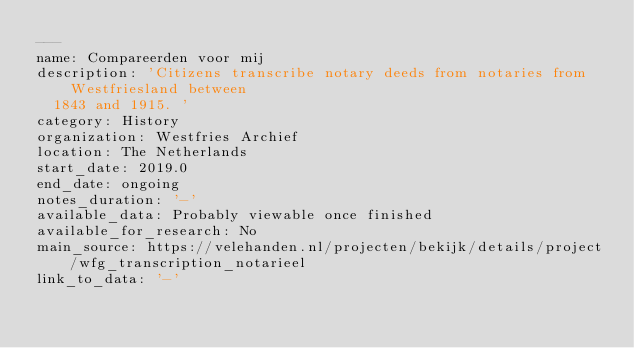Convert code to text. <code><loc_0><loc_0><loc_500><loc_500><_YAML_>---
name: Compareerden voor mij
description: 'Citizens transcribe notary deeds from notaries from Westfriesland between
  1843 and 1915. '
category: History
organization: Westfries Archief
location: The Netherlands
start_date: 2019.0
end_date: ongoing
notes_duration: '-'
available_data: Probably viewable once finished
available_for_research: No
main_source: https://velehanden.nl/projecten/bekijk/details/project/wfg_transcription_notarieel
link_to_data: '-'
</code> 